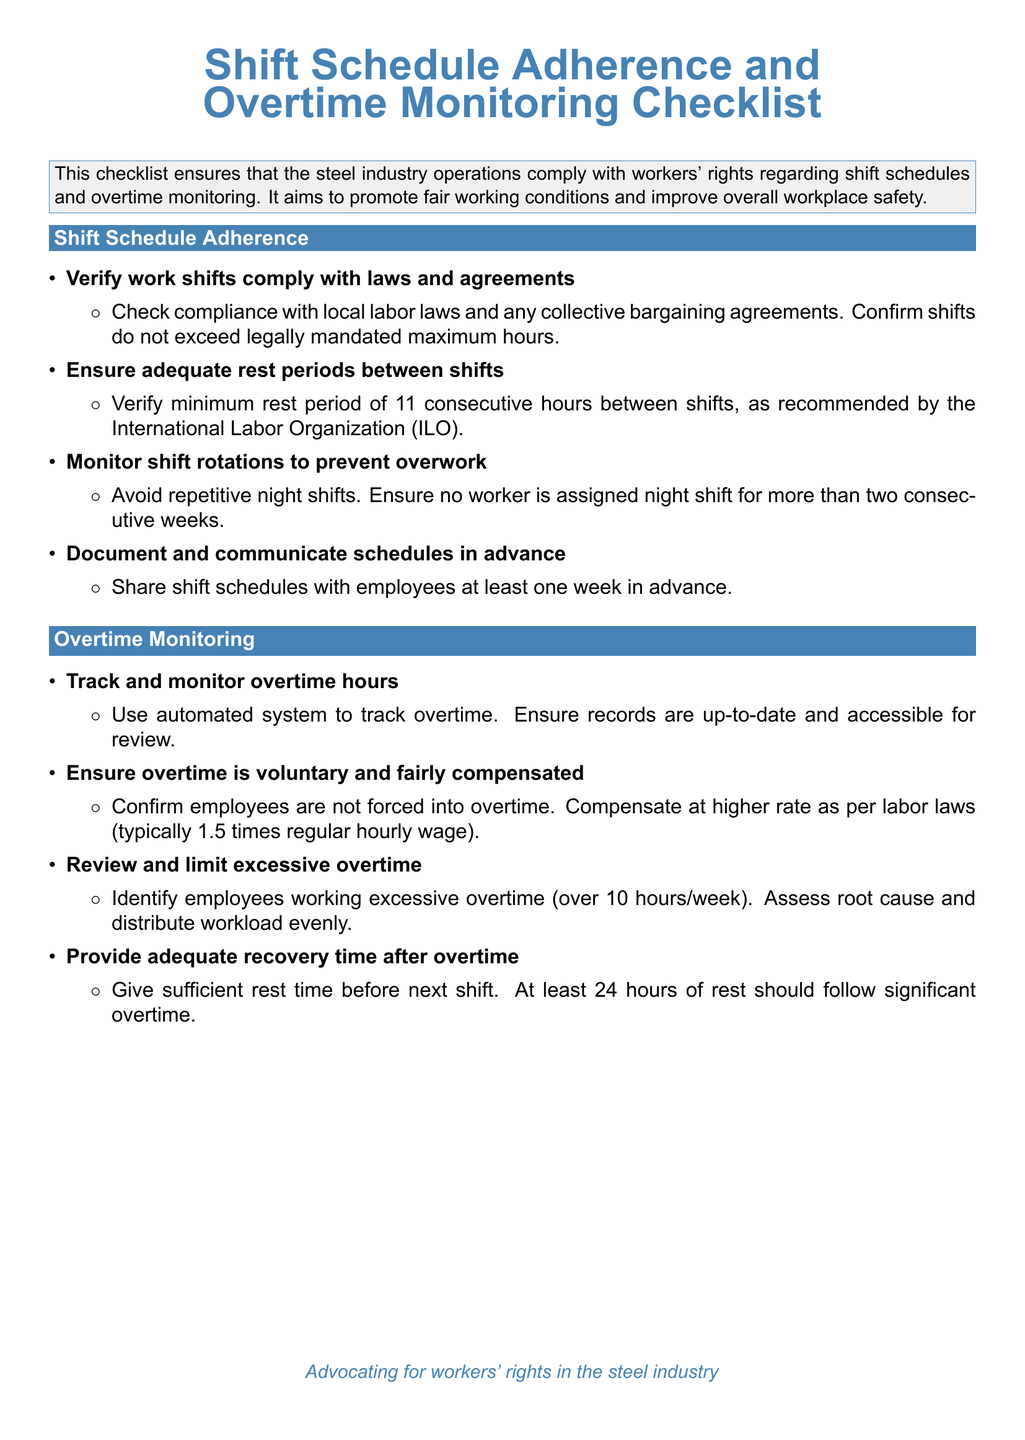What is the title of the document? The title of the document is presented in a prominent format at the top and states the main focus of the content.
Answer: Shift Schedule Adherence and Overtime Monitoring Checklist What is the minimum rest period recommended by the International Labor Organization? The document specifies a minimum rest period that should be adhered to between shifts as per guidelines.
Answer: 11 consecutive hours What should be done to monitor overtime hours? The document outlines specific actions to track overtime hours effectively, indicating a method of monitoring.
Answer: Use automated system What compensation rate is mentioned for overtime work? The document states how workers should be compensated for overtime according to labor laws.
Answer: 1.5 times regular hourly wage How many items are listed under Shift Schedule Adherence? The document includes several checklist items regarding shift schedule adherence, indicating the total number to check.
Answer: 4 What is the purpose of this checklist? The document states the overall goal of the checklist, focusing on compliance and worker welfare.
Answer: Ensure that the steel industry operations comply with workers' rights What is the maximum amount of overtime hours identified as excessive? The checklist sets a threshold for reasonable overtime hours, indicating concern for workers' well-being.
Answer: Over 10 hours/week What should be done after significant overtime according to the checklist? The document advises on what must be provided to workers following significant overtime hours.
Answer: Give sufficient rest time 